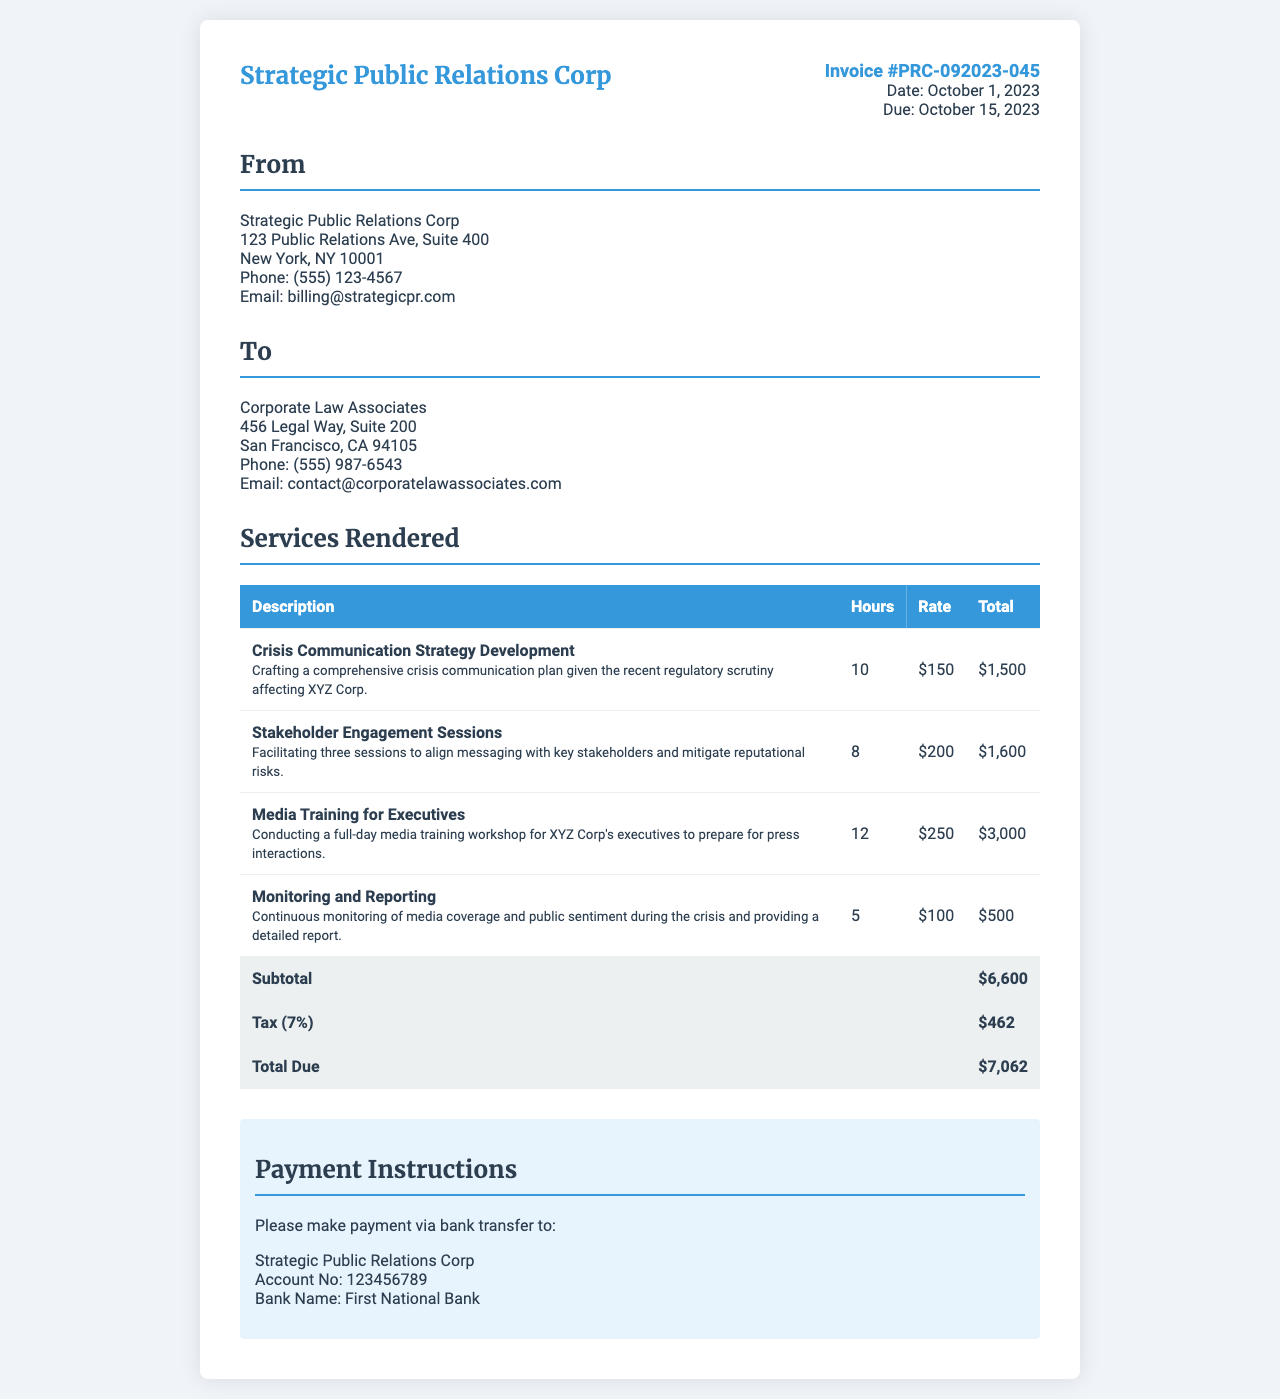What is the invoice number? The invoice number is clearly stated in the document, which is PRC-092023-045.
Answer: PRC-092023-045 When is the due date for the invoice? The due date is specified in the document as October 15, 2023.
Answer: October 15, 2023 What is the total amount due? The total due is calculated at the end of the invoice as $7,062.
Answer: $7,062 How many hours were spent on Media Training for Executives? The number of hours for this service is listed in the invoice as 12 hours.
Answer: 12 What percentage is the tax applied to the subtotal? The tax rate is indicated as 7% in the document.
Answer: 7% What service took the most hours to complete? The service with the highest hours is Media Training for Executives, which took 12 hours.
Answer: Media Training for Executives Who is the sender of the invoice? The sender is identified at the top of the invoice as Strategic Public Relations Corp.
Answer: Strategic Public Relations Corp What is the total cost for Stakeholder Engagement Sessions? The total for this service is calculated as 8 hours multiplied by a rate of $200, which results in $1,600.
Answer: $1,600 